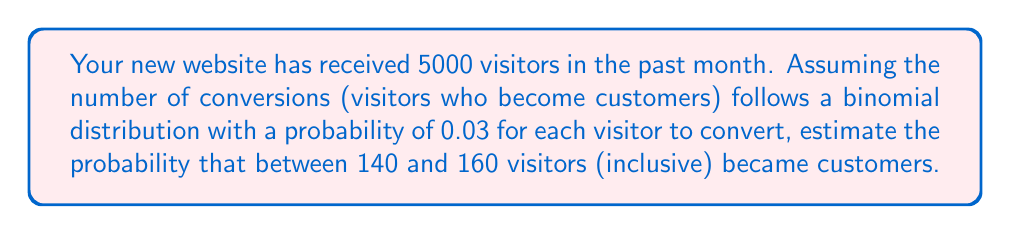Could you help me with this problem? To solve this problem, we'll use the binomial distribution and its normal approximation:

1. Let $X$ be the number of conversions. $X$ follows a binomial distribution with parameters $n=5000$ and $p=0.03$.

2. The mean of this distribution is $\mu = np = 5000 \cdot 0.03 = 150$.

3. The standard deviation is $\sigma = \sqrt{np(1-p)} = \sqrt{5000 \cdot 0.03 \cdot 0.97} \approx 12.08$.

4. Since $n$ is large and $np > 5$, we can use the normal approximation to the binomial distribution.

5. We need to find $P(140 \leq X \leq 160)$.

6. Applying the continuity correction, we calculate:

   $P(139.5 \leq X \leq 160.5)$

7. Standardizing these values:
   
   $z_1 = \frac{139.5 - 150}{12.08} \approx -0.87$
   $z_2 = \frac{160.5 - 150}{12.08} \approx 0.87$

8. Using the standard normal distribution:

   $P(-0.87 \leq Z \leq 0.87) = \Phi(0.87) - \Phi(-0.87)$

9. From the standard normal table or calculator:

   $\Phi(0.87) \approx 0.8078$
   $\Phi(-0.87) \approx 0.1922$

10. Therefore, the probability is:

    $0.8078 - 0.1922 = 0.6156$
Answer: The probability that between 140 and 160 visitors (inclusive) became customers is approximately 0.6156 or 61.56%. 